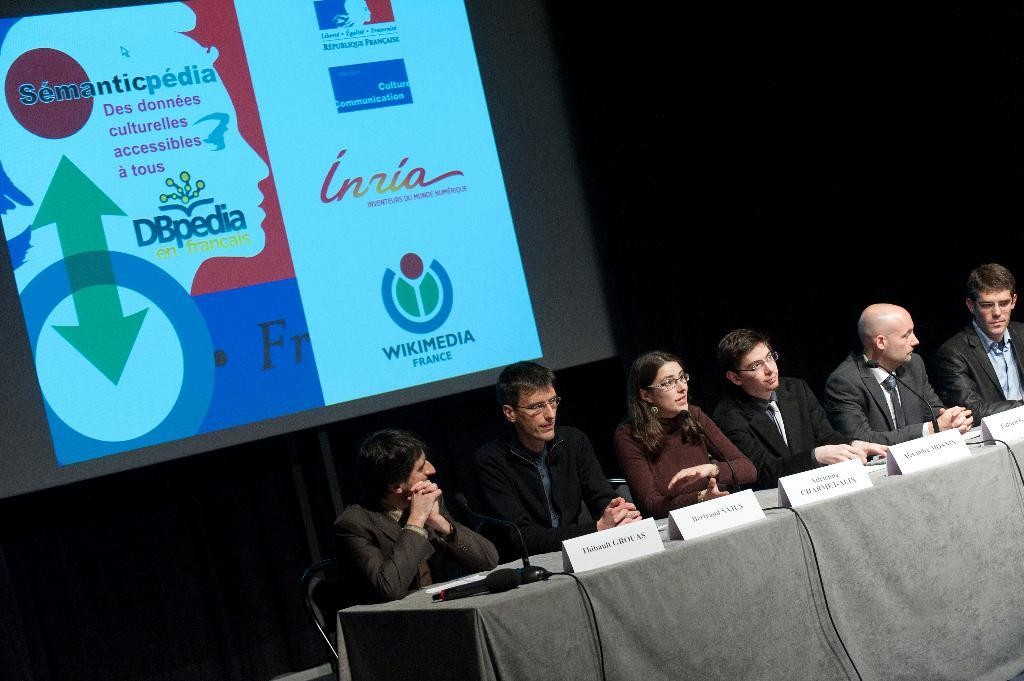What can be seen in the background of the image? There is a screen in the background of the image. What are the people in the image doing? The persons are sitting on chairs in front of a table. What objects are present on the table? Name boards and microphones (mike's) are on the table. What month is it in the image? The month cannot be determined from the image, as there is no information about the date or time of year. Is there a park visible in the image? There is no park present in the image. 